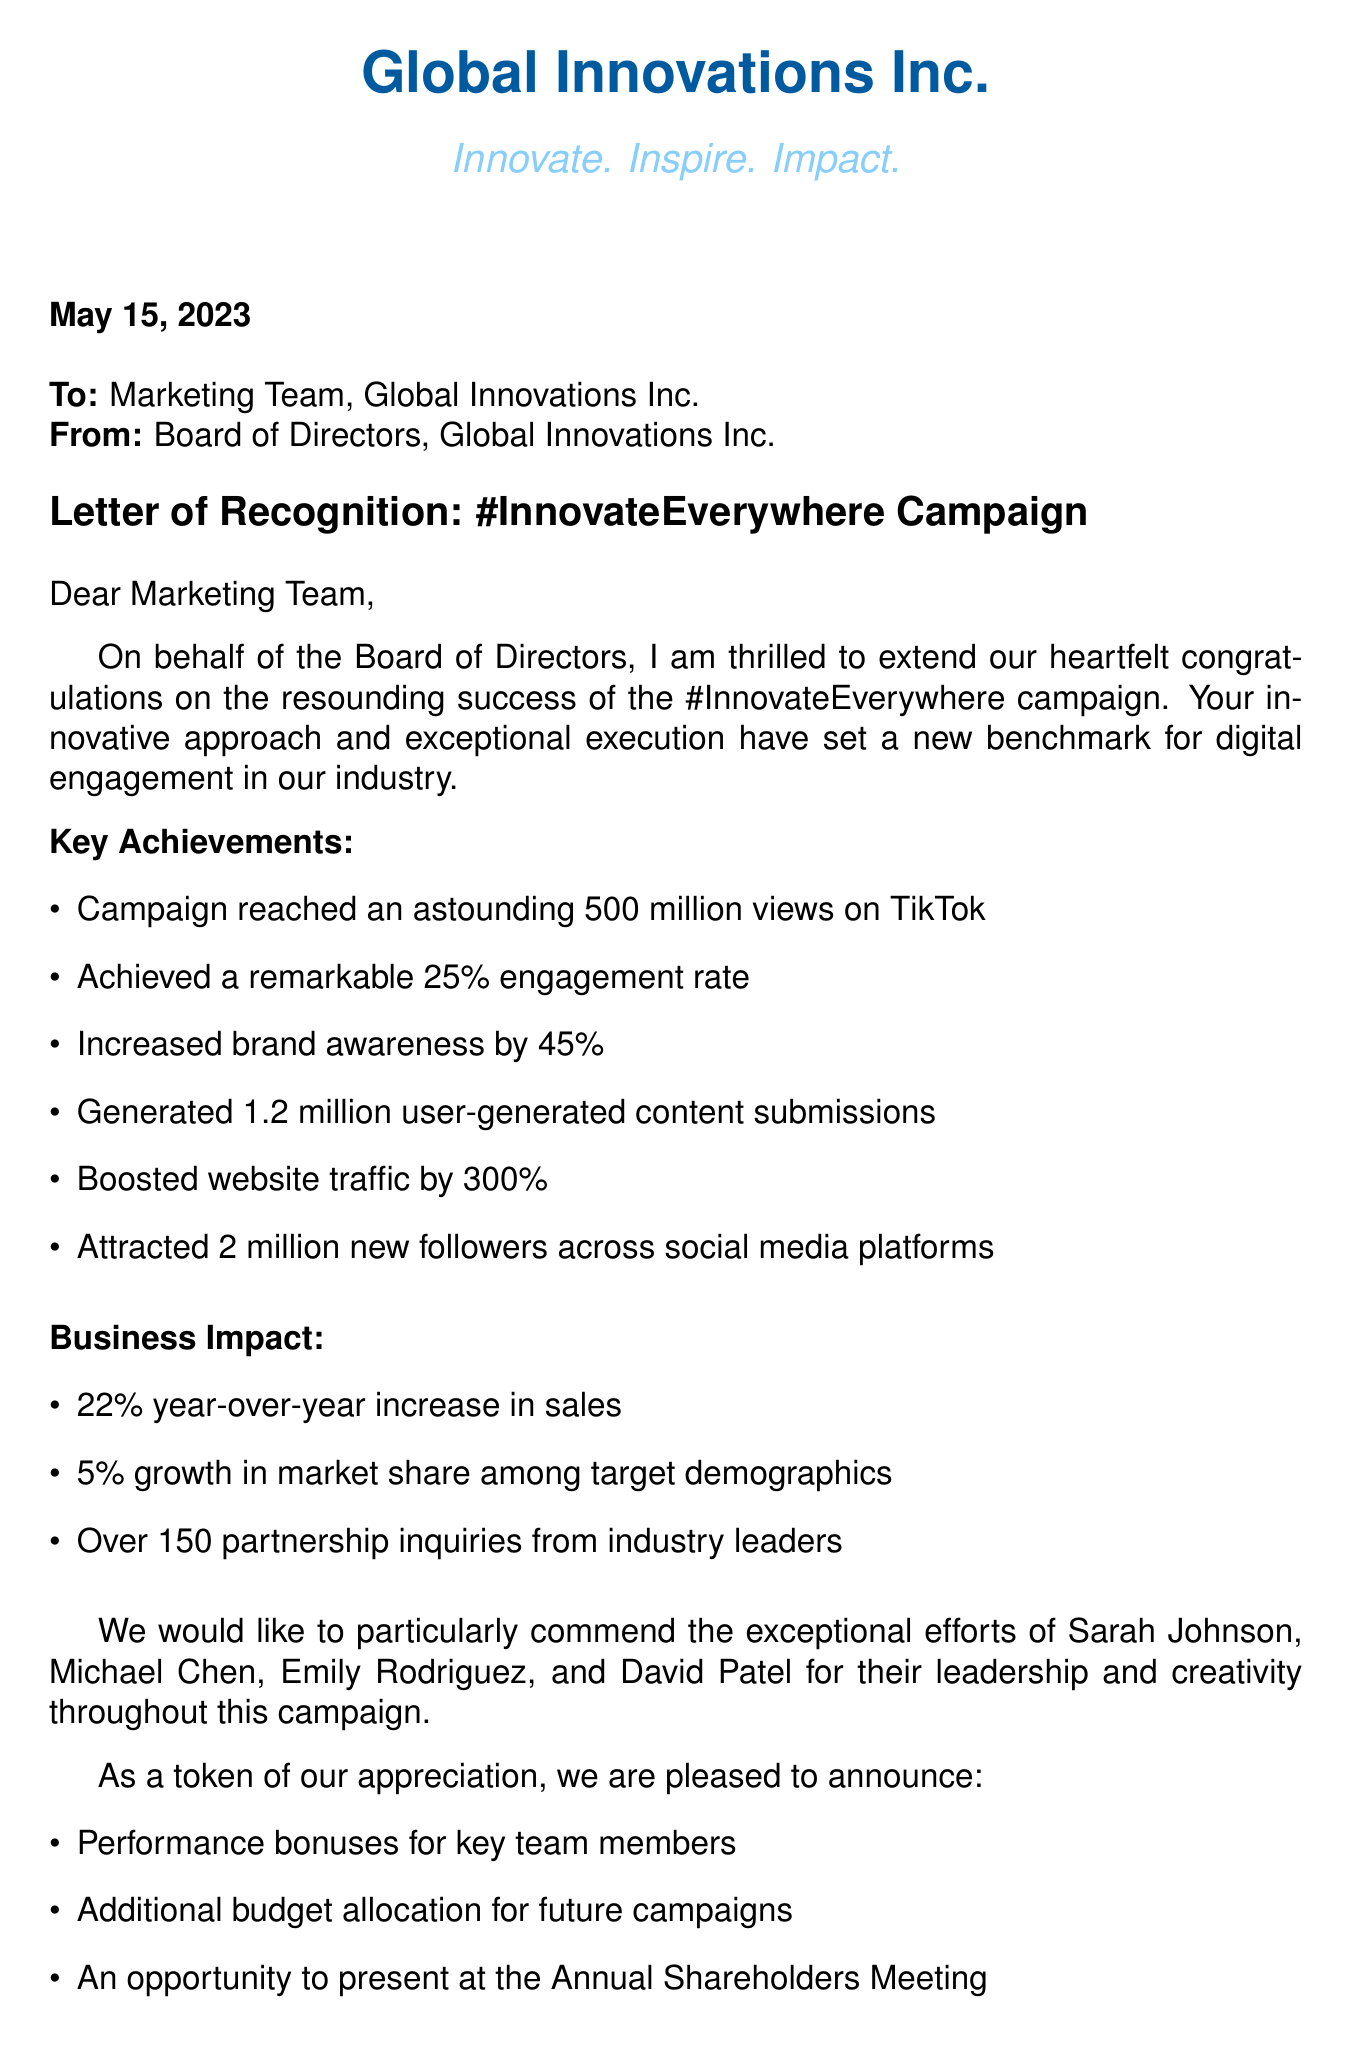What is the name of the campaign? The name of the campaign is explicitly stated in the letter as "#InnovateEverywhere".
Answer: #InnovateEverywhere Who is the recipient of the letter? The recipient of the letter is indicated at the beginning as "Marketing Team, Global Innovations Inc."
Answer: Marketing Team, Global Innovations Inc What was the engagement rate of the campaign? The engagement rate is provided in the achievements section as "25%".
Answer: 25% How many new followers were attracted from the campaign? The number of new followers gained is mentioned as "2 million" in the key achievements.
Answer: 2 million Who are the members recognized for their efforts? The members recognized for their contributions are listed, including "Sarah Johnson, Michael Chen, Emily Rodriguez, David Patel".
Answer: Sarah Johnson, Michael Chen, Emily Rodriguez, David Patel What percentage increase in sales was reported? The letter specifies that there was a "22% year-over-year increase in sales".
Answer: 22% What future perspective is mentioned regarding the campaign? Future perspectives include "Expansion of the campaign to emerging markets", as noted in the document.
Answer: Expansion of the campaign to emerging markets What is the date of the letter? The letter starts with the date specified as "May 15, 2023".
Answer: May 15, 2023 What is the quote from the Chairperson? The Chairperson's quote about the campaign is included, emphasizing that it "set a new standard for digital engagement".
Answer: The marketing team's innovative approach has set a new standard for digital engagement in our industry 